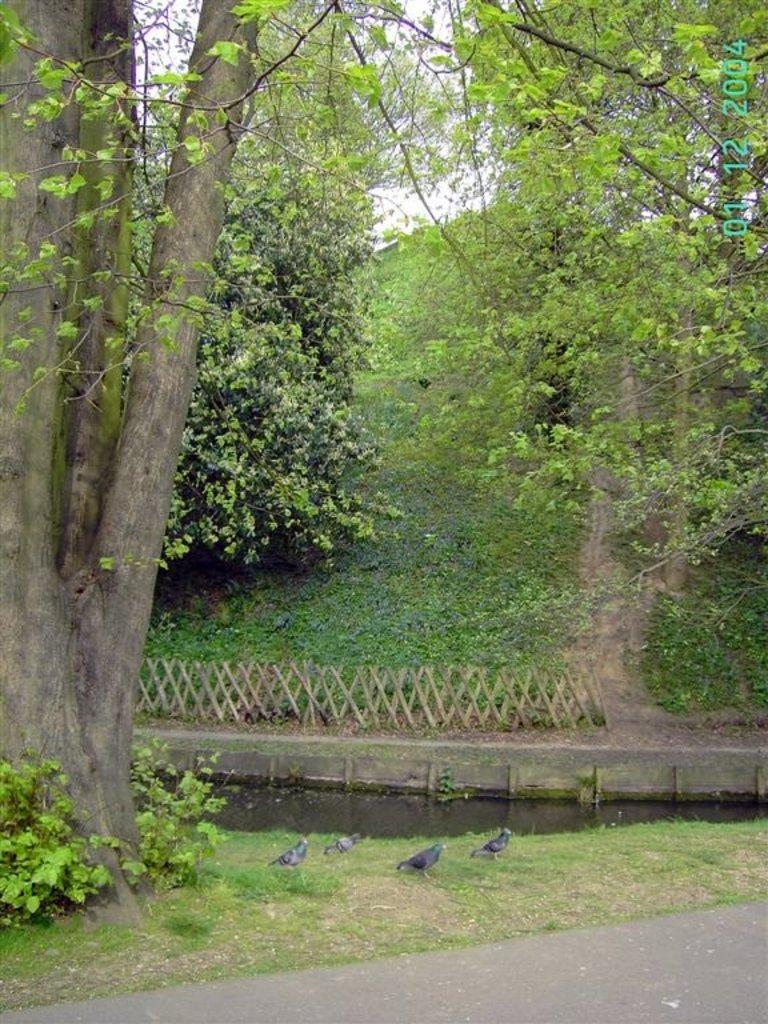What type of vegetation is present on the grass surface in the image? There are trees on a grass surface in the image. Are there any other plants visible near the trees? Yes, there are plants near the trees. What can be seen between the trees in the image? The sky is visible between the trees in the image. What type of ice can be seen melting on the grass surface in the image? There is no ice present in the image; it features trees, plants, and the sky. What reaction can be observed between the trees and the plants in the image? There is no reaction between the trees and the plants in the image; they are simply coexisting in the same environment. 